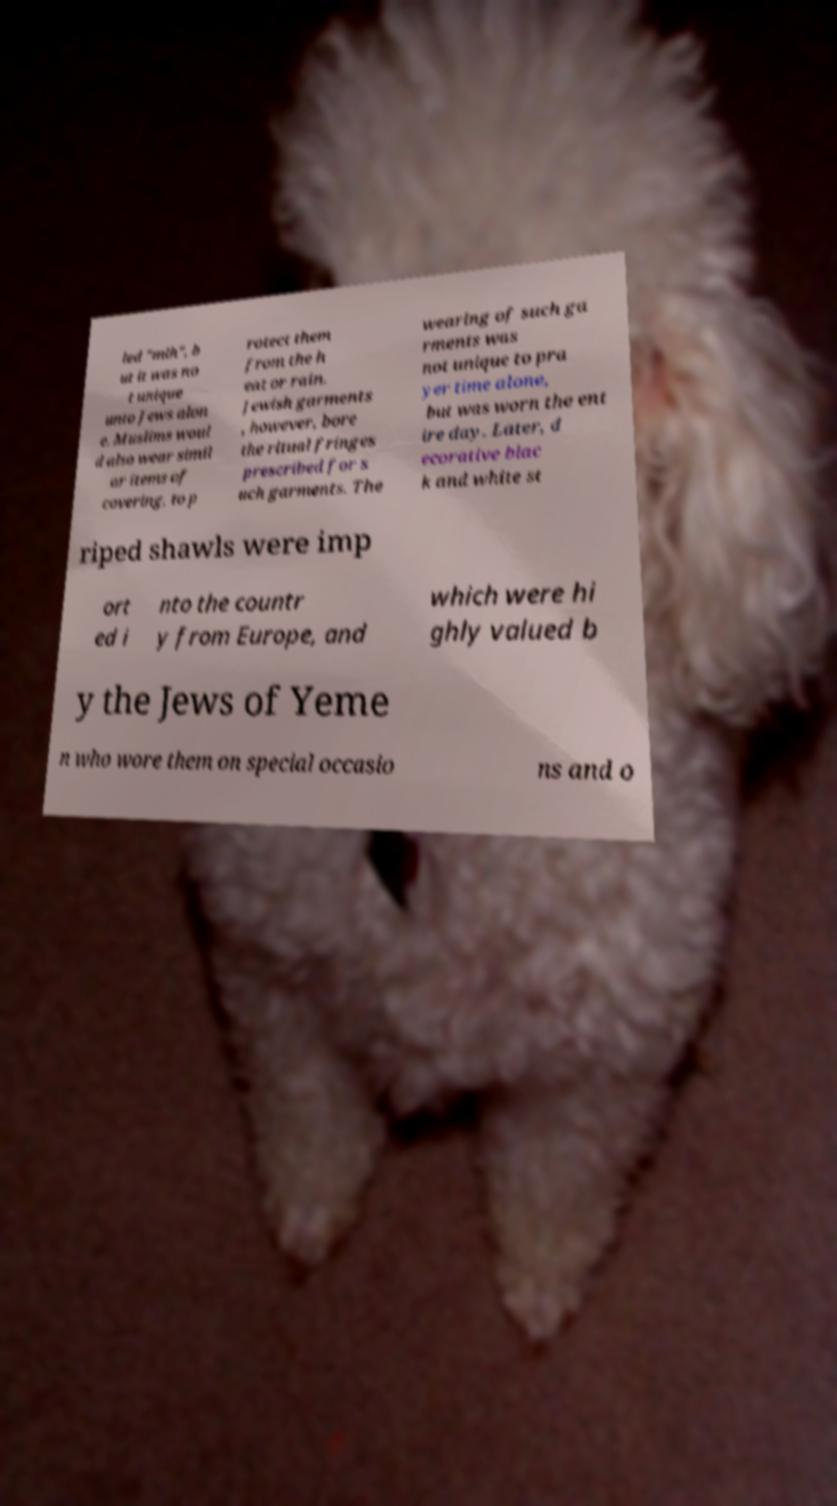Can you read and provide the text displayed in the image?This photo seems to have some interesting text. Can you extract and type it out for me? led "mlh", b ut it was no t unique unto Jews alon e. Muslims woul d also wear simil ar items of covering, to p rotect them from the h eat or rain. Jewish garments , however, bore the ritual fringes prescribed for s uch garments. The wearing of such ga rments was not unique to pra yer time alone, but was worn the ent ire day. Later, d ecorative blac k and white st riped shawls were imp ort ed i nto the countr y from Europe, and which were hi ghly valued b y the Jews of Yeme n who wore them on special occasio ns and o 